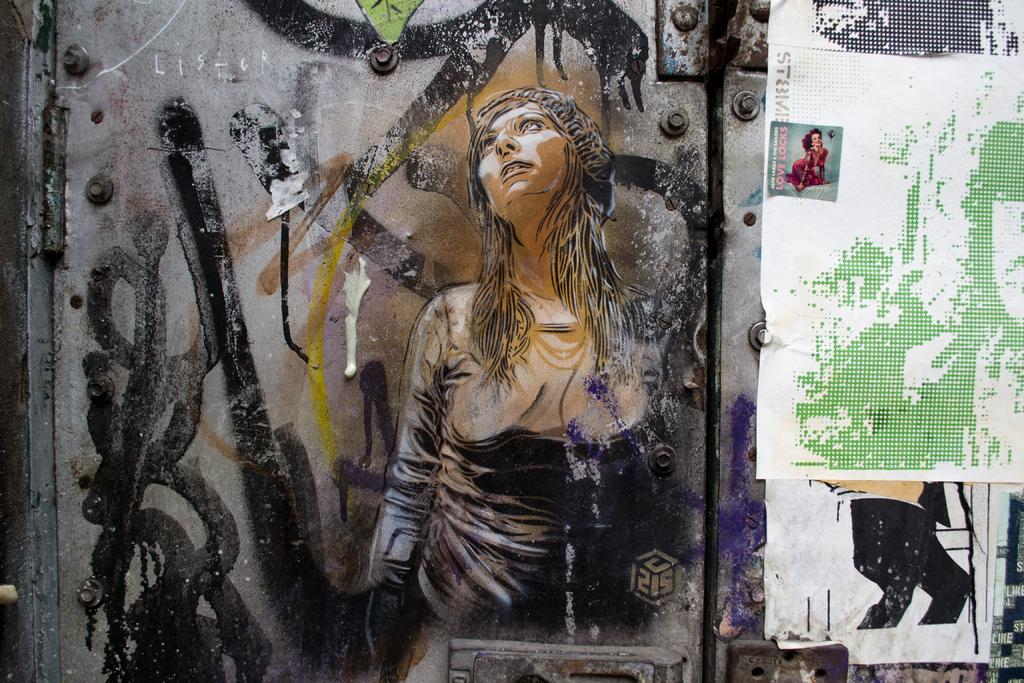What is present on the wall in the image? There is a painting of a woman and a poster on the wall. Can you describe the painting on the wall? The painting on the wall is of a woman. What else is featured on the wall besides the painting? There is also a poster on the wall. How many eyes can be seen on the hill in the image? There are no eyes or hills present in the image; it features a wall with a painting of a woman and a poster. What type of harbor is visible in the image? There is no harbor present in the image. 